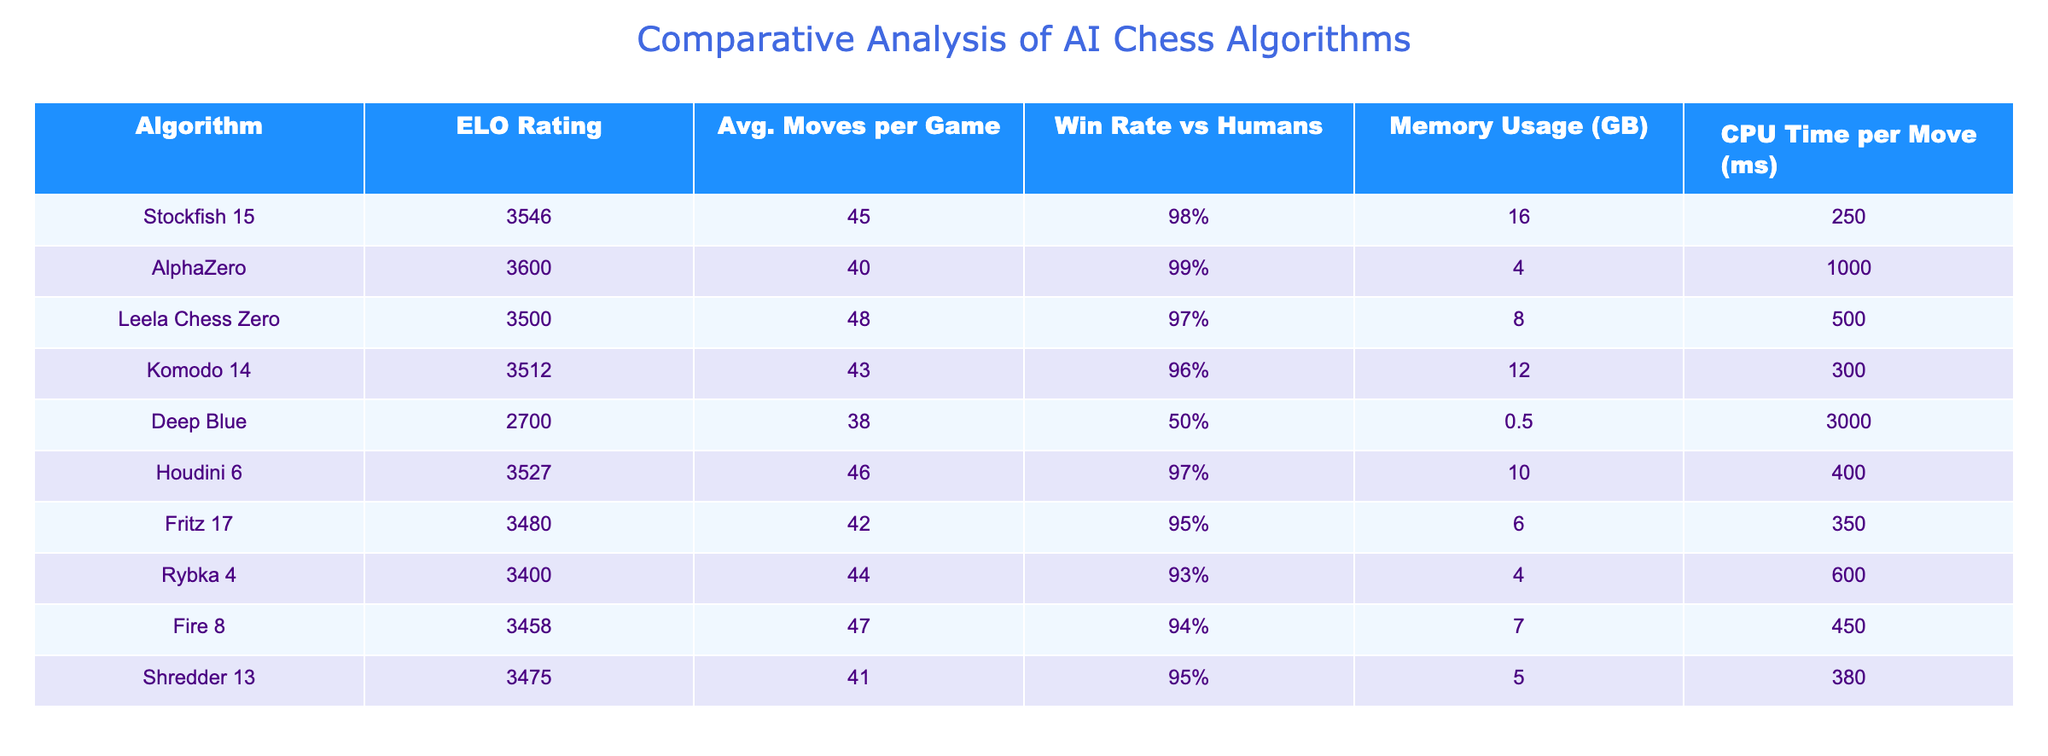What is the ELO rating of AlphaZero? The ELO rating of AlphaZero is explicitly listed in the table under the "ELO Rating" column. The value next to "AlphaZero" is 3600.
Answer: 3600 Which algorithm has the highest win rate against humans? By scanning the "Win Rate vs Humans" column, we find that AlphaZero has the highest win rate of 99%.
Answer: 99% How many algorithms have an average moves per game greater than 45? We can count the entries in the "Avg. Moves per Game" column where the value exceeds 45. The algorithms meeting this criterion are Stockfish 15, Leela Chess Zero, Houdini 6, Fire 8, totaling 4 algorithms.
Answer: 4 What is the difference between the ELO ratings of Stockfish 15 and Deep Blue? To find this difference, we subtract the ELO rating of Deep Blue (2700) from Stockfish 15 (3546). So, 3546 - 2700 = 846.
Answer: 846 Is it true that Fritz 17 uses more memory than Rybka 4? Looking at the "Memory Usage (GB)" column, Fritz 17 has a usage of 6 GB while Rybka 4 has 4 GB. Since 6 GB is greater than 4 GB, the statement is true.
Answer: Yes What is the average CPU time per move of all the algorithms? To calculate the average, we sum the values in the "CPU Time per Move (ms)" column: 250 + 1000 + 500 + 300 + 3000 + 400 + 350 + 600 + 450 = 2550. Next, divide by the total number of algorithms (9): 2550/9 = approximately 283.33 ms.
Answer: 283.33 ms Which algorithm has the lowest win rate against humans, and what is that rate? By examining the "Win Rate vs Humans" column, we see that Deep Blue has the lowest win rate at 50%.
Answer: Deep Blue, 50% How much more CPU time per move does Deep Blue require compared to AlphaZero? The CPU time per move for Deep Blue is 3000 ms and for AlphaZero, it is 1000 ms. Hence, the difference is 3000 - 1000 = 2000 ms.
Answer: 2000 ms 